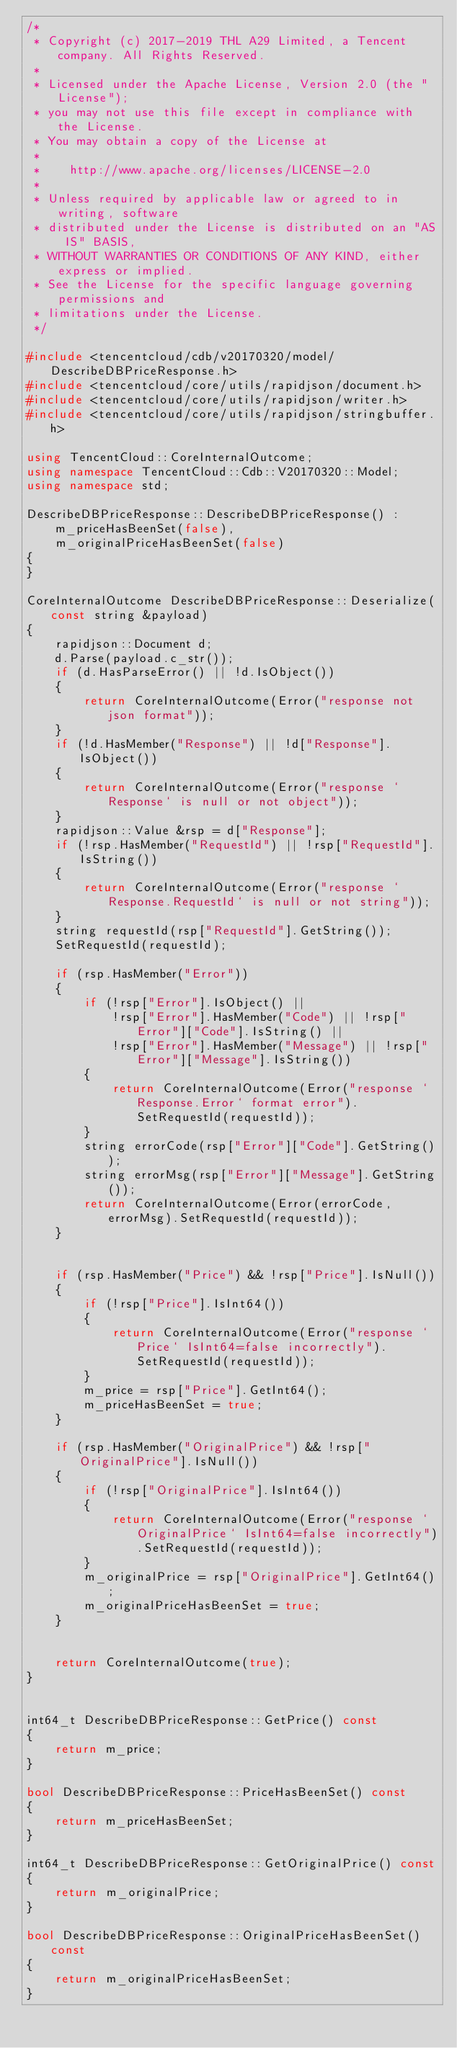<code> <loc_0><loc_0><loc_500><loc_500><_C++_>/*
 * Copyright (c) 2017-2019 THL A29 Limited, a Tencent company. All Rights Reserved.
 *
 * Licensed under the Apache License, Version 2.0 (the "License");
 * you may not use this file except in compliance with the License.
 * You may obtain a copy of the License at
 *
 *    http://www.apache.org/licenses/LICENSE-2.0
 *
 * Unless required by applicable law or agreed to in writing, software
 * distributed under the License is distributed on an "AS IS" BASIS,
 * WITHOUT WARRANTIES OR CONDITIONS OF ANY KIND, either express or implied.
 * See the License for the specific language governing permissions and
 * limitations under the License.
 */

#include <tencentcloud/cdb/v20170320/model/DescribeDBPriceResponse.h>
#include <tencentcloud/core/utils/rapidjson/document.h>
#include <tencentcloud/core/utils/rapidjson/writer.h>
#include <tencentcloud/core/utils/rapidjson/stringbuffer.h>

using TencentCloud::CoreInternalOutcome;
using namespace TencentCloud::Cdb::V20170320::Model;
using namespace std;

DescribeDBPriceResponse::DescribeDBPriceResponse() :
    m_priceHasBeenSet(false),
    m_originalPriceHasBeenSet(false)
{
}

CoreInternalOutcome DescribeDBPriceResponse::Deserialize(const string &payload)
{
    rapidjson::Document d;
    d.Parse(payload.c_str());
    if (d.HasParseError() || !d.IsObject())
    {
        return CoreInternalOutcome(Error("response not json format"));
    }
    if (!d.HasMember("Response") || !d["Response"].IsObject())
    {
        return CoreInternalOutcome(Error("response `Response` is null or not object"));
    }
    rapidjson::Value &rsp = d["Response"];
    if (!rsp.HasMember("RequestId") || !rsp["RequestId"].IsString())
    {
        return CoreInternalOutcome(Error("response `Response.RequestId` is null or not string"));
    }
    string requestId(rsp["RequestId"].GetString());
    SetRequestId(requestId);

    if (rsp.HasMember("Error"))
    {
        if (!rsp["Error"].IsObject() ||
            !rsp["Error"].HasMember("Code") || !rsp["Error"]["Code"].IsString() ||
            !rsp["Error"].HasMember("Message") || !rsp["Error"]["Message"].IsString())
        {
            return CoreInternalOutcome(Error("response `Response.Error` format error").SetRequestId(requestId));
        }
        string errorCode(rsp["Error"]["Code"].GetString());
        string errorMsg(rsp["Error"]["Message"].GetString());
        return CoreInternalOutcome(Error(errorCode, errorMsg).SetRequestId(requestId));
    }


    if (rsp.HasMember("Price") && !rsp["Price"].IsNull())
    {
        if (!rsp["Price"].IsInt64())
        {
            return CoreInternalOutcome(Error("response `Price` IsInt64=false incorrectly").SetRequestId(requestId));
        }
        m_price = rsp["Price"].GetInt64();
        m_priceHasBeenSet = true;
    }

    if (rsp.HasMember("OriginalPrice") && !rsp["OriginalPrice"].IsNull())
    {
        if (!rsp["OriginalPrice"].IsInt64())
        {
            return CoreInternalOutcome(Error("response `OriginalPrice` IsInt64=false incorrectly").SetRequestId(requestId));
        }
        m_originalPrice = rsp["OriginalPrice"].GetInt64();
        m_originalPriceHasBeenSet = true;
    }


    return CoreInternalOutcome(true);
}


int64_t DescribeDBPriceResponse::GetPrice() const
{
    return m_price;
}

bool DescribeDBPriceResponse::PriceHasBeenSet() const
{
    return m_priceHasBeenSet;
}

int64_t DescribeDBPriceResponse::GetOriginalPrice() const
{
    return m_originalPrice;
}

bool DescribeDBPriceResponse::OriginalPriceHasBeenSet() const
{
    return m_originalPriceHasBeenSet;
}


</code> 